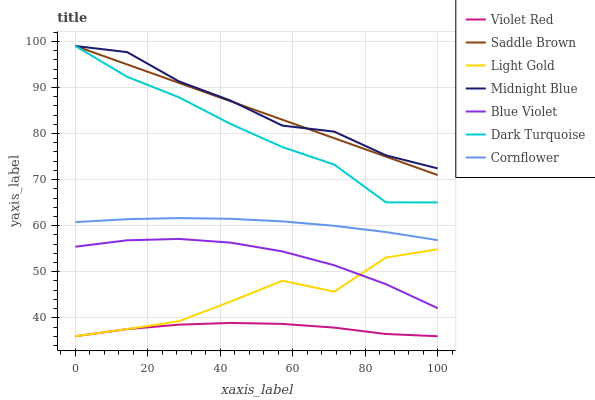Does Midnight Blue have the minimum area under the curve?
Answer yes or no. No. Does Violet Red have the maximum area under the curve?
Answer yes or no. No. Is Violet Red the smoothest?
Answer yes or no. No. Is Violet Red the roughest?
Answer yes or no. No. Does Midnight Blue have the lowest value?
Answer yes or no. No. Does Violet Red have the highest value?
Answer yes or no. No. Is Cornflower less than Saddle Brown?
Answer yes or no. Yes. Is Saddle Brown greater than Violet Red?
Answer yes or no. Yes. Does Cornflower intersect Saddle Brown?
Answer yes or no. No. 